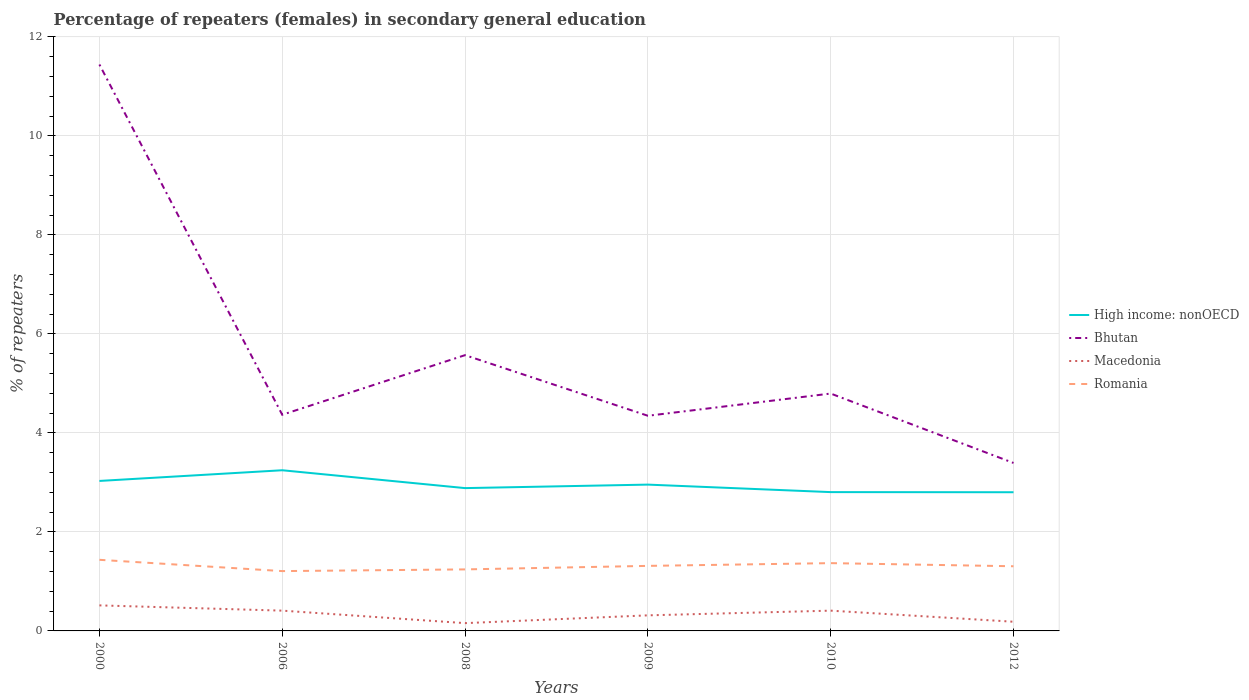How many different coloured lines are there?
Make the answer very short. 4. Does the line corresponding to Macedonia intersect with the line corresponding to Romania?
Your response must be concise. No. Across all years, what is the maximum percentage of female repeaters in High income: nonOECD?
Your response must be concise. 2.8. In which year was the percentage of female repeaters in Macedonia maximum?
Your response must be concise. 2008. What is the total percentage of female repeaters in Bhutan in the graph?
Ensure brevity in your answer.  0.95. What is the difference between the highest and the second highest percentage of female repeaters in High income: nonOECD?
Your answer should be very brief. 0.44. What is the difference between the highest and the lowest percentage of female repeaters in Macedonia?
Make the answer very short. 3. Is the percentage of female repeaters in Romania strictly greater than the percentage of female repeaters in High income: nonOECD over the years?
Your answer should be very brief. Yes. How many lines are there?
Offer a very short reply. 4. Does the graph contain any zero values?
Provide a short and direct response. No. How many legend labels are there?
Your answer should be very brief. 4. How are the legend labels stacked?
Provide a short and direct response. Vertical. What is the title of the graph?
Offer a very short reply. Percentage of repeaters (females) in secondary general education. Does "Romania" appear as one of the legend labels in the graph?
Your answer should be compact. Yes. What is the label or title of the Y-axis?
Your answer should be compact. % of repeaters. What is the % of repeaters in High income: nonOECD in 2000?
Give a very brief answer. 3.03. What is the % of repeaters of Bhutan in 2000?
Provide a short and direct response. 11.44. What is the % of repeaters in Macedonia in 2000?
Offer a very short reply. 0.52. What is the % of repeaters in Romania in 2000?
Your answer should be very brief. 1.44. What is the % of repeaters of High income: nonOECD in 2006?
Your response must be concise. 3.25. What is the % of repeaters of Bhutan in 2006?
Keep it short and to the point. 4.37. What is the % of repeaters of Macedonia in 2006?
Provide a short and direct response. 0.41. What is the % of repeaters in Romania in 2006?
Ensure brevity in your answer.  1.21. What is the % of repeaters of High income: nonOECD in 2008?
Your response must be concise. 2.89. What is the % of repeaters of Bhutan in 2008?
Ensure brevity in your answer.  5.57. What is the % of repeaters in Macedonia in 2008?
Provide a short and direct response. 0.16. What is the % of repeaters in Romania in 2008?
Your answer should be very brief. 1.24. What is the % of repeaters of High income: nonOECD in 2009?
Your response must be concise. 2.96. What is the % of repeaters of Bhutan in 2009?
Your answer should be very brief. 4.35. What is the % of repeaters of Macedonia in 2009?
Your answer should be compact. 0.31. What is the % of repeaters of Romania in 2009?
Provide a short and direct response. 1.31. What is the % of repeaters of High income: nonOECD in 2010?
Provide a succinct answer. 2.8. What is the % of repeaters in Bhutan in 2010?
Your answer should be compact. 4.8. What is the % of repeaters in Macedonia in 2010?
Your answer should be compact. 0.41. What is the % of repeaters of Romania in 2010?
Ensure brevity in your answer.  1.37. What is the % of repeaters in High income: nonOECD in 2012?
Offer a very short reply. 2.8. What is the % of repeaters of Bhutan in 2012?
Give a very brief answer. 3.39. What is the % of repeaters of Macedonia in 2012?
Your response must be concise. 0.19. What is the % of repeaters in Romania in 2012?
Your response must be concise. 1.31. Across all years, what is the maximum % of repeaters in High income: nonOECD?
Your answer should be compact. 3.25. Across all years, what is the maximum % of repeaters of Bhutan?
Your answer should be compact. 11.44. Across all years, what is the maximum % of repeaters in Macedonia?
Ensure brevity in your answer.  0.52. Across all years, what is the maximum % of repeaters of Romania?
Your answer should be very brief. 1.44. Across all years, what is the minimum % of repeaters in High income: nonOECD?
Make the answer very short. 2.8. Across all years, what is the minimum % of repeaters in Bhutan?
Offer a terse response. 3.39. Across all years, what is the minimum % of repeaters in Macedonia?
Ensure brevity in your answer.  0.16. Across all years, what is the minimum % of repeaters of Romania?
Your answer should be compact. 1.21. What is the total % of repeaters in High income: nonOECD in the graph?
Keep it short and to the point. 17.72. What is the total % of repeaters of Bhutan in the graph?
Your response must be concise. 33.92. What is the total % of repeaters of Macedonia in the graph?
Ensure brevity in your answer.  1.99. What is the total % of repeaters in Romania in the graph?
Make the answer very short. 7.88. What is the difference between the % of repeaters of High income: nonOECD in 2000 and that in 2006?
Your answer should be very brief. -0.22. What is the difference between the % of repeaters in Bhutan in 2000 and that in 2006?
Provide a short and direct response. 7.08. What is the difference between the % of repeaters in Macedonia in 2000 and that in 2006?
Your answer should be compact. 0.11. What is the difference between the % of repeaters in Romania in 2000 and that in 2006?
Ensure brevity in your answer.  0.23. What is the difference between the % of repeaters in High income: nonOECD in 2000 and that in 2008?
Provide a succinct answer. 0.14. What is the difference between the % of repeaters in Bhutan in 2000 and that in 2008?
Offer a very short reply. 5.87. What is the difference between the % of repeaters in Macedonia in 2000 and that in 2008?
Provide a short and direct response. 0.36. What is the difference between the % of repeaters in Romania in 2000 and that in 2008?
Give a very brief answer. 0.19. What is the difference between the % of repeaters of High income: nonOECD in 2000 and that in 2009?
Your response must be concise. 0.07. What is the difference between the % of repeaters in Bhutan in 2000 and that in 2009?
Ensure brevity in your answer.  7.1. What is the difference between the % of repeaters in Macedonia in 2000 and that in 2009?
Your answer should be very brief. 0.2. What is the difference between the % of repeaters in Romania in 2000 and that in 2009?
Your answer should be compact. 0.12. What is the difference between the % of repeaters of High income: nonOECD in 2000 and that in 2010?
Your answer should be compact. 0.23. What is the difference between the % of repeaters in Bhutan in 2000 and that in 2010?
Make the answer very short. 6.65. What is the difference between the % of repeaters of Macedonia in 2000 and that in 2010?
Offer a terse response. 0.11. What is the difference between the % of repeaters of Romania in 2000 and that in 2010?
Provide a succinct answer. 0.07. What is the difference between the % of repeaters of High income: nonOECD in 2000 and that in 2012?
Provide a short and direct response. 0.23. What is the difference between the % of repeaters in Bhutan in 2000 and that in 2012?
Keep it short and to the point. 8.05. What is the difference between the % of repeaters in Macedonia in 2000 and that in 2012?
Your answer should be very brief. 0.33. What is the difference between the % of repeaters in Romania in 2000 and that in 2012?
Ensure brevity in your answer.  0.13. What is the difference between the % of repeaters in High income: nonOECD in 2006 and that in 2008?
Ensure brevity in your answer.  0.36. What is the difference between the % of repeaters in Bhutan in 2006 and that in 2008?
Your answer should be very brief. -1.2. What is the difference between the % of repeaters of Macedonia in 2006 and that in 2008?
Give a very brief answer. 0.25. What is the difference between the % of repeaters of Romania in 2006 and that in 2008?
Give a very brief answer. -0.03. What is the difference between the % of repeaters of High income: nonOECD in 2006 and that in 2009?
Your answer should be compact. 0.29. What is the difference between the % of repeaters of Bhutan in 2006 and that in 2009?
Your answer should be compact. 0.02. What is the difference between the % of repeaters of Macedonia in 2006 and that in 2009?
Your answer should be very brief. 0.1. What is the difference between the % of repeaters of Romania in 2006 and that in 2009?
Your response must be concise. -0.11. What is the difference between the % of repeaters in High income: nonOECD in 2006 and that in 2010?
Provide a succinct answer. 0.44. What is the difference between the % of repeaters of Bhutan in 2006 and that in 2010?
Provide a short and direct response. -0.43. What is the difference between the % of repeaters in Romania in 2006 and that in 2010?
Provide a short and direct response. -0.16. What is the difference between the % of repeaters in High income: nonOECD in 2006 and that in 2012?
Provide a short and direct response. 0.44. What is the difference between the % of repeaters of Bhutan in 2006 and that in 2012?
Ensure brevity in your answer.  0.97. What is the difference between the % of repeaters of Macedonia in 2006 and that in 2012?
Your answer should be compact. 0.22. What is the difference between the % of repeaters of Romania in 2006 and that in 2012?
Offer a very short reply. -0.1. What is the difference between the % of repeaters of High income: nonOECD in 2008 and that in 2009?
Give a very brief answer. -0.07. What is the difference between the % of repeaters in Bhutan in 2008 and that in 2009?
Offer a terse response. 1.22. What is the difference between the % of repeaters of Macedonia in 2008 and that in 2009?
Make the answer very short. -0.16. What is the difference between the % of repeaters of Romania in 2008 and that in 2009?
Your answer should be very brief. -0.07. What is the difference between the % of repeaters in High income: nonOECD in 2008 and that in 2010?
Offer a terse response. 0.08. What is the difference between the % of repeaters of Bhutan in 2008 and that in 2010?
Offer a very short reply. 0.78. What is the difference between the % of repeaters in Macedonia in 2008 and that in 2010?
Make the answer very short. -0.25. What is the difference between the % of repeaters of Romania in 2008 and that in 2010?
Give a very brief answer. -0.13. What is the difference between the % of repeaters of High income: nonOECD in 2008 and that in 2012?
Offer a very short reply. 0.08. What is the difference between the % of repeaters of Bhutan in 2008 and that in 2012?
Provide a short and direct response. 2.18. What is the difference between the % of repeaters in Macedonia in 2008 and that in 2012?
Offer a very short reply. -0.03. What is the difference between the % of repeaters of Romania in 2008 and that in 2012?
Keep it short and to the point. -0.06. What is the difference between the % of repeaters in High income: nonOECD in 2009 and that in 2010?
Ensure brevity in your answer.  0.15. What is the difference between the % of repeaters in Bhutan in 2009 and that in 2010?
Your response must be concise. -0.45. What is the difference between the % of repeaters of Macedonia in 2009 and that in 2010?
Offer a terse response. -0.1. What is the difference between the % of repeaters in Romania in 2009 and that in 2010?
Offer a very short reply. -0.06. What is the difference between the % of repeaters of High income: nonOECD in 2009 and that in 2012?
Give a very brief answer. 0.15. What is the difference between the % of repeaters in Bhutan in 2009 and that in 2012?
Your response must be concise. 0.95. What is the difference between the % of repeaters of Macedonia in 2009 and that in 2012?
Offer a very short reply. 0.13. What is the difference between the % of repeaters of Romania in 2009 and that in 2012?
Give a very brief answer. 0.01. What is the difference between the % of repeaters in High income: nonOECD in 2010 and that in 2012?
Offer a terse response. 0. What is the difference between the % of repeaters of Bhutan in 2010 and that in 2012?
Keep it short and to the point. 1.4. What is the difference between the % of repeaters of Macedonia in 2010 and that in 2012?
Provide a succinct answer. 0.22. What is the difference between the % of repeaters in Romania in 2010 and that in 2012?
Provide a short and direct response. 0.06. What is the difference between the % of repeaters in High income: nonOECD in 2000 and the % of repeaters in Bhutan in 2006?
Give a very brief answer. -1.34. What is the difference between the % of repeaters of High income: nonOECD in 2000 and the % of repeaters of Macedonia in 2006?
Ensure brevity in your answer.  2.62. What is the difference between the % of repeaters of High income: nonOECD in 2000 and the % of repeaters of Romania in 2006?
Provide a succinct answer. 1.82. What is the difference between the % of repeaters of Bhutan in 2000 and the % of repeaters of Macedonia in 2006?
Offer a terse response. 11.03. What is the difference between the % of repeaters in Bhutan in 2000 and the % of repeaters in Romania in 2006?
Provide a succinct answer. 10.23. What is the difference between the % of repeaters of Macedonia in 2000 and the % of repeaters of Romania in 2006?
Your response must be concise. -0.69. What is the difference between the % of repeaters in High income: nonOECD in 2000 and the % of repeaters in Bhutan in 2008?
Provide a succinct answer. -2.54. What is the difference between the % of repeaters in High income: nonOECD in 2000 and the % of repeaters in Macedonia in 2008?
Offer a terse response. 2.87. What is the difference between the % of repeaters in High income: nonOECD in 2000 and the % of repeaters in Romania in 2008?
Your answer should be very brief. 1.79. What is the difference between the % of repeaters in Bhutan in 2000 and the % of repeaters in Macedonia in 2008?
Provide a short and direct response. 11.29. What is the difference between the % of repeaters of Bhutan in 2000 and the % of repeaters of Romania in 2008?
Keep it short and to the point. 10.2. What is the difference between the % of repeaters in Macedonia in 2000 and the % of repeaters in Romania in 2008?
Offer a very short reply. -0.73. What is the difference between the % of repeaters of High income: nonOECD in 2000 and the % of repeaters of Bhutan in 2009?
Ensure brevity in your answer.  -1.32. What is the difference between the % of repeaters in High income: nonOECD in 2000 and the % of repeaters in Macedonia in 2009?
Your answer should be compact. 2.72. What is the difference between the % of repeaters in High income: nonOECD in 2000 and the % of repeaters in Romania in 2009?
Offer a terse response. 1.72. What is the difference between the % of repeaters of Bhutan in 2000 and the % of repeaters of Macedonia in 2009?
Your answer should be compact. 11.13. What is the difference between the % of repeaters of Bhutan in 2000 and the % of repeaters of Romania in 2009?
Provide a short and direct response. 10.13. What is the difference between the % of repeaters in Macedonia in 2000 and the % of repeaters in Romania in 2009?
Your response must be concise. -0.8. What is the difference between the % of repeaters of High income: nonOECD in 2000 and the % of repeaters of Bhutan in 2010?
Provide a succinct answer. -1.77. What is the difference between the % of repeaters in High income: nonOECD in 2000 and the % of repeaters in Macedonia in 2010?
Give a very brief answer. 2.62. What is the difference between the % of repeaters of High income: nonOECD in 2000 and the % of repeaters of Romania in 2010?
Your response must be concise. 1.66. What is the difference between the % of repeaters in Bhutan in 2000 and the % of repeaters in Macedonia in 2010?
Make the answer very short. 11.03. What is the difference between the % of repeaters in Bhutan in 2000 and the % of repeaters in Romania in 2010?
Offer a very short reply. 10.07. What is the difference between the % of repeaters in Macedonia in 2000 and the % of repeaters in Romania in 2010?
Your response must be concise. -0.85. What is the difference between the % of repeaters of High income: nonOECD in 2000 and the % of repeaters of Bhutan in 2012?
Your answer should be compact. -0.36. What is the difference between the % of repeaters in High income: nonOECD in 2000 and the % of repeaters in Macedonia in 2012?
Make the answer very short. 2.84. What is the difference between the % of repeaters of High income: nonOECD in 2000 and the % of repeaters of Romania in 2012?
Provide a succinct answer. 1.72. What is the difference between the % of repeaters of Bhutan in 2000 and the % of repeaters of Macedonia in 2012?
Make the answer very short. 11.26. What is the difference between the % of repeaters in Bhutan in 2000 and the % of repeaters in Romania in 2012?
Provide a short and direct response. 10.14. What is the difference between the % of repeaters of Macedonia in 2000 and the % of repeaters of Romania in 2012?
Your answer should be compact. -0.79. What is the difference between the % of repeaters of High income: nonOECD in 2006 and the % of repeaters of Bhutan in 2008?
Your answer should be compact. -2.33. What is the difference between the % of repeaters of High income: nonOECD in 2006 and the % of repeaters of Macedonia in 2008?
Your response must be concise. 3.09. What is the difference between the % of repeaters in High income: nonOECD in 2006 and the % of repeaters in Romania in 2008?
Your answer should be very brief. 2. What is the difference between the % of repeaters in Bhutan in 2006 and the % of repeaters in Macedonia in 2008?
Give a very brief answer. 4.21. What is the difference between the % of repeaters of Bhutan in 2006 and the % of repeaters of Romania in 2008?
Your answer should be very brief. 3.12. What is the difference between the % of repeaters in Macedonia in 2006 and the % of repeaters in Romania in 2008?
Provide a short and direct response. -0.83. What is the difference between the % of repeaters of High income: nonOECD in 2006 and the % of repeaters of Bhutan in 2009?
Ensure brevity in your answer.  -1.1. What is the difference between the % of repeaters in High income: nonOECD in 2006 and the % of repeaters in Macedonia in 2009?
Keep it short and to the point. 2.93. What is the difference between the % of repeaters in High income: nonOECD in 2006 and the % of repeaters in Romania in 2009?
Ensure brevity in your answer.  1.93. What is the difference between the % of repeaters in Bhutan in 2006 and the % of repeaters in Macedonia in 2009?
Offer a terse response. 4.05. What is the difference between the % of repeaters in Bhutan in 2006 and the % of repeaters in Romania in 2009?
Keep it short and to the point. 3.05. What is the difference between the % of repeaters of Macedonia in 2006 and the % of repeaters of Romania in 2009?
Offer a terse response. -0.9. What is the difference between the % of repeaters of High income: nonOECD in 2006 and the % of repeaters of Bhutan in 2010?
Your response must be concise. -1.55. What is the difference between the % of repeaters in High income: nonOECD in 2006 and the % of repeaters in Macedonia in 2010?
Your answer should be very brief. 2.84. What is the difference between the % of repeaters of High income: nonOECD in 2006 and the % of repeaters of Romania in 2010?
Your answer should be compact. 1.88. What is the difference between the % of repeaters of Bhutan in 2006 and the % of repeaters of Macedonia in 2010?
Offer a terse response. 3.96. What is the difference between the % of repeaters in Bhutan in 2006 and the % of repeaters in Romania in 2010?
Your answer should be compact. 3. What is the difference between the % of repeaters of Macedonia in 2006 and the % of repeaters of Romania in 2010?
Offer a very short reply. -0.96. What is the difference between the % of repeaters in High income: nonOECD in 2006 and the % of repeaters in Bhutan in 2012?
Keep it short and to the point. -0.15. What is the difference between the % of repeaters in High income: nonOECD in 2006 and the % of repeaters in Macedonia in 2012?
Offer a terse response. 3.06. What is the difference between the % of repeaters in High income: nonOECD in 2006 and the % of repeaters in Romania in 2012?
Offer a terse response. 1.94. What is the difference between the % of repeaters of Bhutan in 2006 and the % of repeaters of Macedonia in 2012?
Make the answer very short. 4.18. What is the difference between the % of repeaters of Bhutan in 2006 and the % of repeaters of Romania in 2012?
Your answer should be very brief. 3.06. What is the difference between the % of repeaters of Macedonia in 2006 and the % of repeaters of Romania in 2012?
Your answer should be very brief. -0.9. What is the difference between the % of repeaters in High income: nonOECD in 2008 and the % of repeaters in Bhutan in 2009?
Give a very brief answer. -1.46. What is the difference between the % of repeaters in High income: nonOECD in 2008 and the % of repeaters in Macedonia in 2009?
Offer a very short reply. 2.57. What is the difference between the % of repeaters in High income: nonOECD in 2008 and the % of repeaters in Romania in 2009?
Provide a succinct answer. 1.57. What is the difference between the % of repeaters of Bhutan in 2008 and the % of repeaters of Macedonia in 2009?
Your answer should be very brief. 5.26. What is the difference between the % of repeaters of Bhutan in 2008 and the % of repeaters of Romania in 2009?
Make the answer very short. 4.26. What is the difference between the % of repeaters in Macedonia in 2008 and the % of repeaters in Romania in 2009?
Provide a succinct answer. -1.16. What is the difference between the % of repeaters in High income: nonOECD in 2008 and the % of repeaters in Bhutan in 2010?
Ensure brevity in your answer.  -1.91. What is the difference between the % of repeaters of High income: nonOECD in 2008 and the % of repeaters of Macedonia in 2010?
Your answer should be very brief. 2.48. What is the difference between the % of repeaters in High income: nonOECD in 2008 and the % of repeaters in Romania in 2010?
Make the answer very short. 1.52. What is the difference between the % of repeaters of Bhutan in 2008 and the % of repeaters of Macedonia in 2010?
Offer a very short reply. 5.16. What is the difference between the % of repeaters in Bhutan in 2008 and the % of repeaters in Romania in 2010?
Make the answer very short. 4.2. What is the difference between the % of repeaters in Macedonia in 2008 and the % of repeaters in Romania in 2010?
Offer a very short reply. -1.21. What is the difference between the % of repeaters of High income: nonOECD in 2008 and the % of repeaters of Bhutan in 2012?
Make the answer very short. -0.51. What is the difference between the % of repeaters in High income: nonOECD in 2008 and the % of repeaters in Macedonia in 2012?
Provide a succinct answer. 2.7. What is the difference between the % of repeaters in High income: nonOECD in 2008 and the % of repeaters in Romania in 2012?
Give a very brief answer. 1.58. What is the difference between the % of repeaters in Bhutan in 2008 and the % of repeaters in Macedonia in 2012?
Make the answer very short. 5.39. What is the difference between the % of repeaters in Bhutan in 2008 and the % of repeaters in Romania in 2012?
Provide a short and direct response. 4.26. What is the difference between the % of repeaters in Macedonia in 2008 and the % of repeaters in Romania in 2012?
Give a very brief answer. -1.15. What is the difference between the % of repeaters of High income: nonOECD in 2009 and the % of repeaters of Bhutan in 2010?
Make the answer very short. -1.84. What is the difference between the % of repeaters in High income: nonOECD in 2009 and the % of repeaters in Macedonia in 2010?
Provide a succinct answer. 2.55. What is the difference between the % of repeaters of High income: nonOECD in 2009 and the % of repeaters of Romania in 2010?
Offer a very short reply. 1.59. What is the difference between the % of repeaters in Bhutan in 2009 and the % of repeaters in Macedonia in 2010?
Keep it short and to the point. 3.94. What is the difference between the % of repeaters in Bhutan in 2009 and the % of repeaters in Romania in 2010?
Your answer should be compact. 2.98. What is the difference between the % of repeaters of Macedonia in 2009 and the % of repeaters of Romania in 2010?
Your response must be concise. -1.05. What is the difference between the % of repeaters in High income: nonOECD in 2009 and the % of repeaters in Bhutan in 2012?
Your response must be concise. -0.44. What is the difference between the % of repeaters in High income: nonOECD in 2009 and the % of repeaters in Macedonia in 2012?
Your response must be concise. 2.77. What is the difference between the % of repeaters of High income: nonOECD in 2009 and the % of repeaters of Romania in 2012?
Keep it short and to the point. 1.65. What is the difference between the % of repeaters of Bhutan in 2009 and the % of repeaters of Macedonia in 2012?
Give a very brief answer. 4.16. What is the difference between the % of repeaters in Bhutan in 2009 and the % of repeaters in Romania in 2012?
Your answer should be compact. 3.04. What is the difference between the % of repeaters of Macedonia in 2009 and the % of repeaters of Romania in 2012?
Ensure brevity in your answer.  -0.99. What is the difference between the % of repeaters of High income: nonOECD in 2010 and the % of repeaters of Bhutan in 2012?
Offer a very short reply. -0.59. What is the difference between the % of repeaters in High income: nonOECD in 2010 and the % of repeaters in Macedonia in 2012?
Your response must be concise. 2.62. What is the difference between the % of repeaters in High income: nonOECD in 2010 and the % of repeaters in Romania in 2012?
Your answer should be compact. 1.5. What is the difference between the % of repeaters of Bhutan in 2010 and the % of repeaters of Macedonia in 2012?
Provide a short and direct response. 4.61. What is the difference between the % of repeaters in Bhutan in 2010 and the % of repeaters in Romania in 2012?
Provide a succinct answer. 3.49. What is the difference between the % of repeaters of Macedonia in 2010 and the % of repeaters of Romania in 2012?
Make the answer very short. -0.9. What is the average % of repeaters of High income: nonOECD per year?
Provide a succinct answer. 2.95. What is the average % of repeaters of Bhutan per year?
Give a very brief answer. 5.65. What is the average % of repeaters in Macedonia per year?
Offer a terse response. 0.33. What is the average % of repeaters in Romania per year?
Provide a short and direct response. 1.31. In the year 2000, what is the difference between the % of repeaters in High income: nonOECD and % of repeaters in Bhutan?
Your response must be concise. -8.41. In the year 2000, what is the difference between the % of repeaters in High income: nonOECD and % of repeaters in Macedonia?
Keep it short and to the point. 2.51. In the year 2000, what is the difference between the % of repeaters of High income: nonOECD and % of repeaters of Romania?
Provide a short and direct response. 1.59. In the year 2000, what is the difference between the % of repeaters of Bhutan and % of repeaters of Macedonia?
Provide a short and direct response. 10.93. In the year 2000, what is the difference between the % of repeaters in Bhutan and % of repeaters in Romania?
Keep it short and to the point. 10.01. In the year 2000, what is the difference between the % of repeaters in Macedonia and % of repeaters in Romania?
Make the answer very short. -0.92. In the year 2006, what is the difference between the % of repeaters in High income: nonOECD and % of repeaters in Bhutan?
Your answer should be compact. -1.12. In the year 2006, what is the difference between the % of repeaters in High income: nonOECD and % of repeaters in Macedonia?
Your answer should be compact. 2.84. In the year 2006, what is the difference between the % of repeaters in High income: nonOECD and % of repeaters in Romania?
Ensure brevity in your answer.  2.04. In the year 2006, what is the difference between the % of repeaters of Bhutan and % of repeaters of Macedonia?
Your answer should be very brief. 3.96. In the year 2006, what is the difference between the % of repeaters of Bhutan and % of repeaters of Romania?
Ensure brevity in your answer.  3.16. In the year 2006, what is the difference between the % of repeaters of Macedonia and % of repeaters of Romania?
Your answer should be compact. -0.8. In the year 2008, what is the difference between the % of repeaters in High income: nonOECD and % of repeaters in Bhutan?
Keep it short and to the point. -2.69. In the year 2008, what is the difference between the % of repeaters in High income: nonOECD and % of repeaters in Macedonia?
Your answer should be very brief. 2.73. In the year 2008, what is the difference between the % of repeaters of High income: nonOECD and % of repeaters of Romania?
Offer a terse response. 1.64. In the year 2008, what is the difference between the % of repeaters in Bhutan and % of repeaters in Macedonia?
Provide a succinct answer. 5.41. In the year 2008, what is the difference between the % of repeaters of Bhutan and % of repeaters of Romania?
Ensure brevity in your answer.  4.33. In the year 2008, what is the difference between the % of repeaters of Macedonia and % of repeaters of Romania?
Keep it short and to the point. -1.09. In the year 2009, what is the difference between the % of repeaters in High income: nonOECD and % of repeaters in Bhutan?
Offer a terse response. -1.39. In the year 2009, what is the difference between the % of repeaters of High income: nonOECD and % of repeaters of Macedonia?
Offer a very short reply. 2.64. In the year 2009, what is the difference between the % of repeaters in High income: nonOECD and % of repeaters in Romania?
Keep it short and to the point. 1.64. In the year 2009, what is the difference between the % of repeaters of Bhutan and % of repeaters of Macedonia?
Your response must be concise. 4.03. In the year 2009, what is the difference between the % of repeaters of Bhutan and % of repeaters of Romania?
Offer a very short reply. 3.03. In the year 2009, what is the difference between the % of repeaters of Macedonia and % of repeaters of Romania?
Make the answer very short. -1. In the year 2010, what is the difference between the % of repeaters in High income: nonOECD and % of repeaters in Bhutan?
Your answer should be compact. -1.99. In the year 2010, what is the difference between the % of repeaters of High income: nonOECD and % of repeaters of Macedonia?
Provide a succinct answer. 2.39. In the year 2010, what is the difference between the % of repeaters of High income: nonOECD and % of repeaters of Romania?
Your answer should be compact. 1.43. In the year 2010, what is the difference between the % of repeaters of Bhutan and % of repeaters of Macedonia?
Your answer should be compact. 4.39. In the year 2010, what is the difference between the % of repeaters of Bhutan and % of repeaters of Romania?
Offer a terse response. 3.43. In the year 2010, what is the difference between the % of repeaters in Macedonia and % of repeaters in Romania?
Give a very brief answer. -0.96. In the year 2012, what is the difference between the % of repeaters of High income: nonOECD and % of repeaters of Bhutan?
Your answer should be compact. -0.59. In the year 2012, what is the difference between the % of repeaters of High income: nonOECD and % of repeaters of Macedonia?
Make the answer very short. 2.62. In the year 2012, what is the difference between the % of repeaters of High income: nonOECD and % of repeaters of Romania?
Your response must be concise. 1.5. In the year 2012, what is the difference between the % of repeaters in Bhutan and % of repeaters in Macedonia?
Offer a very short reply. 3.21. In the year 2012, what is the difference between the % of repeaters in Bhutan and % of repeaters in Romania?
Ensure brevity in your answer.  2.09. In the year 2012, what is the difference between the % of repeaters of Macedonia and % of repeaters of Romania?
Your answer should be compact. -1.12. What is the ratio of the % of repeaters of High income: nonOECD in 2000 to that in 2006?
Your response must be concise. 0.93. What is the ratio of the % of repeaters in Bhutan in 2000 to that in 2006?
Offer a terse response. 2.62. What is the ratio of the % of repeaters of Macedonia in 2000 to that in 2006?
Your answer should be very brief. 1.26. What is the ratio of the % of repeaters in Romania in 2000 to that in 2006?
Provide a short and direct response. 1.19. What is the ratio of the % of repeaters in High income: nonOECD in 2000 to that in 2008?
Offer a very short reply. 1.05. What is the ratio of the % of repeaters in Bhutan in 2000 to that in 2008?
Provide a succinct answer. 2.05. What is the ratio of the % of repeaters in Macedonia in 2000 to that in 2008?
Ensure brevity in your answer.  3.28. What is the ratio of the % of repeaters of Romania in 2000 to that in 2008?
Ensure brevity in your answer.  1.16. What is the ratio of the % of repeaters in High income: nonOECD in 2000 to that in 2009?
Offer a very short reply. 1.03. What is the ratio of the % of repeaters of Bhutan in 2000 to that in 2009?
Your response must be concise. 2.63. What is the ratio of the % of repeaters in Macedonia in 2000 to that in 2009?
Your answer should be very brief. 1.64. What is the ratio of the % of repeaters in Romania in 2000 to that in 2009?
Give a very brief answer. 1.09. What is the ratio of the % of repeaters in High income: nonOECD in 2000 to that in 2010?
Keep it short and to the point. 1.08. What is the ratio of the % of repeaters of Bhutan in 2000 to that in 2010?
Your answer should be compact. 2.39. What is the ratio of the % of repeaters of Macedonia in 2000 to that in 2010?
Keep it short and to the point. 1.26. What is the ratio of the % of repeaters in Romania in 2000 to that in 2010?
Ensure brevity in your answer.  1.05. What is the ratio of the % of repeaters of High income: nonOECD in 2000 to that in 2012?
Keep it short and to the point. 1.08. What is the ratio of the % of repeaters in Bhutan in 2000 to that in 2012?
Provide a succinct answer. 3.37. What is the ratio of the % of repeaters of Macedonia in 2000 to that in 2012?
Keep it short and to the point. 2.78. What is the ratio of the % of repeaters of Romania in 2000 to that in 2012?
Provide a succinct answer. 1.1. What is the ratio of the % of repeaters of High income: nonOECD in 2006 to that in 2008?
Keep it short and to the point. 1.13. What is the ratio of the % of repeaters of Bhutan in 2006 to that in 2008?
Keep it short and to the point. 0.78. What is the ratio of the % of repeaters of Macedonia in 2006 to that in 2008?
Offer a very short reply. 2.6. What is the ratio of the % of repeaters in Romania in 2006 to that in 2008?
Your answer should be compact. 0.97. What is the ratio of the % of repeaters of High income: nonOECD in 2006 to that in 2009?
Offer a terse response. 1.1. What is the ratio of the % of repeaters in Bhutan in 2006 to that in 2009?
Provide a short and direct response. 1. What is the ratio of the % of repeaters in Macedonia in 2006 to that in 2009?
Your answer should be compact. 1.3. What is the ratio of the % of repeaters of Romania in 2006 to that in 2009?
Your answer should be compact. 0.92. What is the ratio of the % of repeaters in High income: nonOECD in 2006 to that in 2010?
Provide a short and direct response. 1.16. What is the ratio of the % of repeaters of Bhutan in 2006 to that in 2010?
Give a very brief answer. 0.91. What is the ratio of the % of repeaters of Romania in 2006 to that in 2010?
Provide a short and direct response. 0.88. What is the ratio of the % of repeaters in High income: nonOECD in 2006 to that in 2012?
Provide a short and direct response. 1.16. What is the ratio of the % of repeaters of Bhutan in 2006 to that in 2012?
Offer a very short reply. 1.29. What is the ratio of the % of repeaters in Macedonia in 2006 to that in 2012?
Give a very brief answer. 2.21. What is the ratio of the % of repeaters in Romania in 2006 to that in 2012?
Make the answer very short. 0.93. What is the ratio of the % of repeaters in High income: nonOECD in 2008 to that in 2009?
Give a very brief answer. 0.98. What is the ratio of the % of repeaters of Bhutan in 2008 to that in 2009?
Offer a terse response. 1.28. What is the ratio of the % of repeaters in Macedonia in 2008 to that in 2009?
Your answer should be compact. 0.5. What is the ratio of the % of repeaters in Romania in 2008 to that in 2009?
Provide a succinct answer. 0.95. What is the ratio of the % of repeaters of High income: nonOECD in 2008 to that in 2010?
Your answer should be very brief. 1.03. What is the ratio of the % of repeaters in Bhutan in 2008 to that in 2010?
Your answer should be very brief. 1.16. What is the ratio of the % of repeaters of Macedonia in 2008 to that in 2010?
Provide a succinct answer. 0.38. What is the ratio of the % of repeaters of Romania in 2008 to that in 2010?
Provide a short and direct response. 0.91. What is the ratio of the % of repeaters in High income: nonOECD in 2008 to that in 2012?
Make the answer very short. 1.03. What is the ratio of the % of repeaters in Bhutan in 2008 to that in 2012?
Give a very brief answer. 1.64. What is the ratio of the % of repeaters of Macedonia in 2008 to that in 2012?
Provide a short and direct response. 0.85. What is the ratio of the % of repeaters of Romania in 2008 to that in 2012?
Provide a short and direct response. 0.95. What is the ratio of the % of repeaters of High income: nonOECD in 2009 to that in 2010?
Make the answer very short. 1.05. What is the ratio of the % of repeaters of Bhutan in 2009 to that in 2010?
Your answer should be compact. 0.91. What is the ratio of the % of repeaters in Macedonia in 2009 to that in 2010?
Your answer should be compact. 0.77. What is the ratio of the % of repeaters of Romania in 2009 to that in 2010?
Give a very brief answer. 0.96. What is the ratio of the % of repeaters of High income: nonOECD in 2009 to that in 2012?
Give a very brief answer. 1.05. What is the ratio of the % of repeaters in Bhutan in 2009 to that in 2012?
Give a very brief answer. 1.28. What is the ratio of the % of repeaters in Macedonia in 2009 to that in 2012?
Your answer should be compact. 1.7. What is the ratio of the % of repeaters of High income: nonOECD in 2010 to that in 2012?
Provide a succinct answer. 1. What is the ratio of the % of repeaters of Bhutan in 2010 to that in 2012?
Provide a short and direct response. 1.41. What is the ratio of the % of repeaters of Macedonia in 2010 to that in 2012?
Make the answer very short. 2.21. What is the ratio of the % of repeaters in Romania in 2010 to that in 2012?
Offer a very short reply. 1.05. What is the difference between the highest and the second highest % of repeaters in High income: nonOECD?
Offer a terse response. 0.22. What is the difference between the highest and the second highest % of repeaters of Bhutan?
Make the answer very short. 5.87. What is the difference between the highest and the second highest % of repeaters in Macedonia?
Make the answer very short. 0.11. What is the difference between the highest and the second highest % of repeaters of Romania?
Keep it short and to the point. 0.07. What is the difference between the highest and the lowest % of repeaters of High income: nonOECD?
Offer a terse response. 0.44. What is the difference between the highest and the lowest % of repeaters in Bhutan?
Ensure brevity in your answer.  8.05. What is the difference between the highest and the lowest % of repeaters in Macedonia?
Provide a short and direct response. 0.36. What is the difference between the highest and the lowest % of repeaters of Romania?
Ensure brevity in your answer.  0.23. 